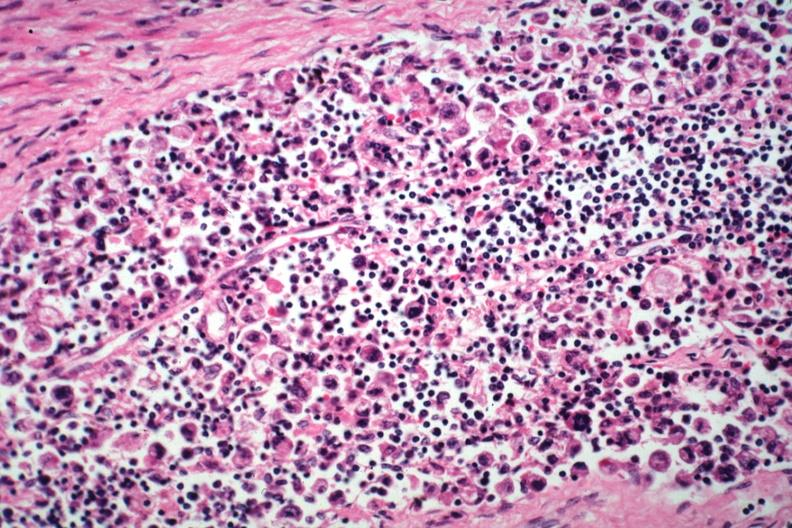does this image show hepatic node anaplastic adenocarcinoma from a one cm sessile prepyloric polyp incidental finding died with promyelocytic leukemia stomach lesion #?
Answer the question using a single word or phrase. Yes 